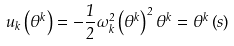Convert formula to latex. <formula><loc_0><loc_0><loc_500><loc_500>u _ { k } \left ( \theta ^ { k } \right ) = - \frac { 1 } { 2 } \omega _ { k } ^ { 2 } \left ( \theta ^ { k } \right ) ^ { 2 } \theta ^ { k } = \theta ^ { k } \left ( s \right )</formula> 